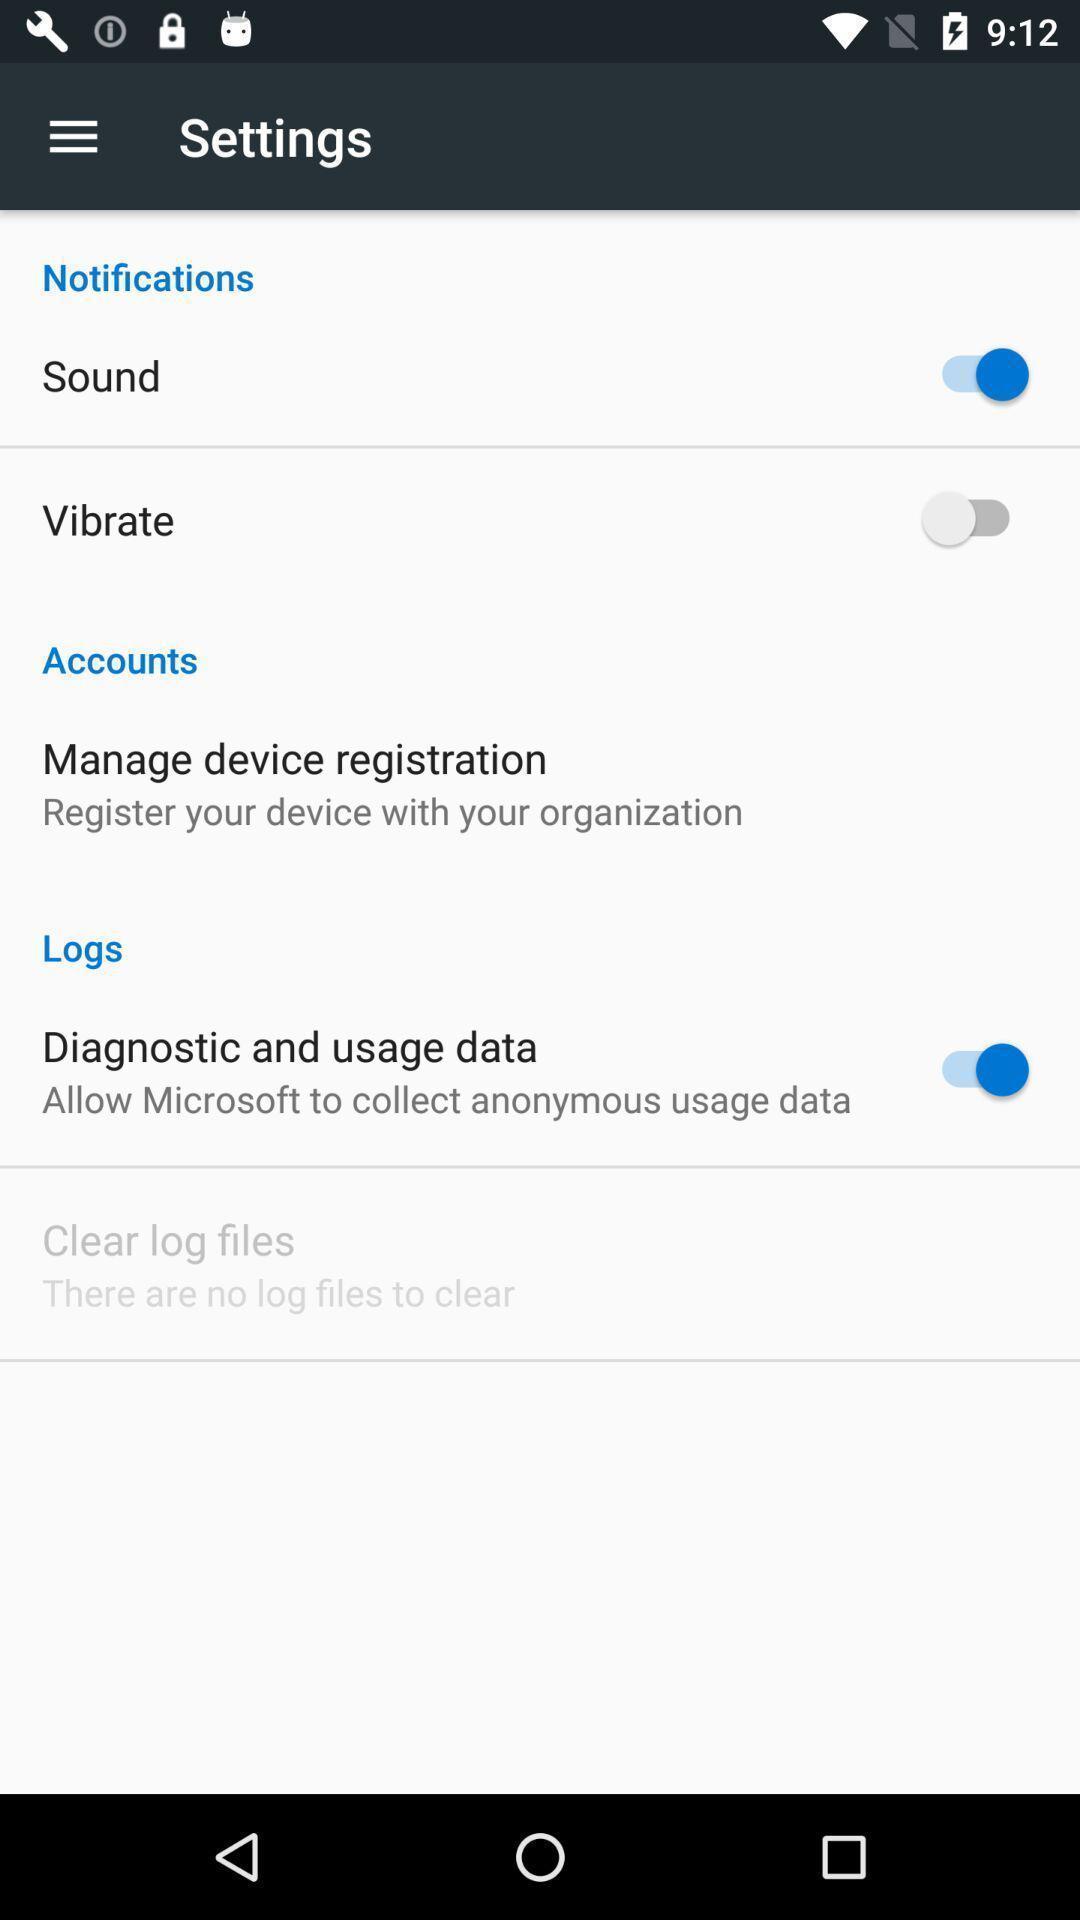Give me a summary of this screen capture. Settings page. 